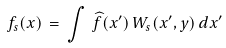<formula> <loc_0><loc_0><loc_500><loc_500>f _ { s } ( { x } ) \, = \, \int \, { \widehat { f } } ( { x ^ { \prime } } ) \, W _ { s } ( { x ^ { \prime } } , { y } ) \, d { x ^ { \prime } }</formula> 